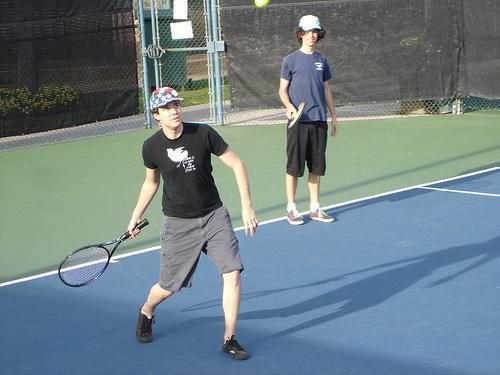How many people are in the image?
Give a very brief answer. 2. 